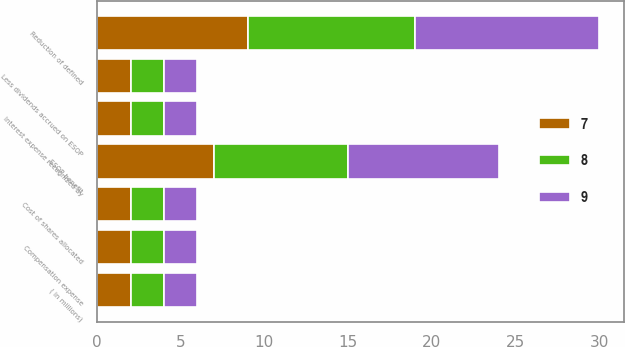Convert chart to OTSL. <chart><loc_0><loc_0><loc_500><loc_500><stacked_bar_chart><ecel><fcel>( in millions)<fcel>Interest expense recognized by<fcel>Less dividends accrued on ESOP<fcel>Cost of shares allocated<fcel>Compensation expense<fcel>Reduction of defined<fcel>ESOP benefit<nl><fcel>8<fcel>2<fcel>2<fcel>2<fcel>2<fcel>2<fcel>10<fcel>8<nl><fcel>7<fcel>2<fcel>2<fcel>2<fcel>2<fcel>2<fcel>9<fcel>7<nl><fcel>9<fcel>2<fcel>2<fcel>2<fcel>2<fcel>2<fcel>11<fcel>9<nl></chart> 